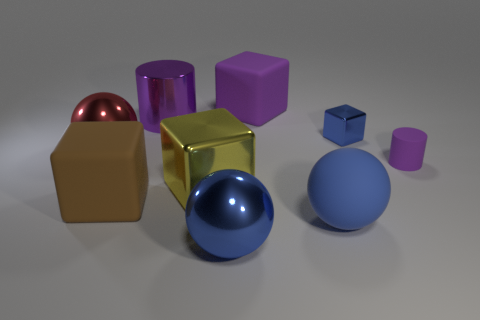Add 1 large matte blocks. How many objects exist? 10 Subtract all balls. How many objects are left? 6 Subtract all small yellow rubber cubes. Subtract all small objects. How many objects are left? 7 Add 6 purple cylinders. How many purple cylinders are left? 8 Add 4 big purple blocks. How many big purple blocks exist? 5 Subtract 0 brown cylinders. How many objects are left? 9 